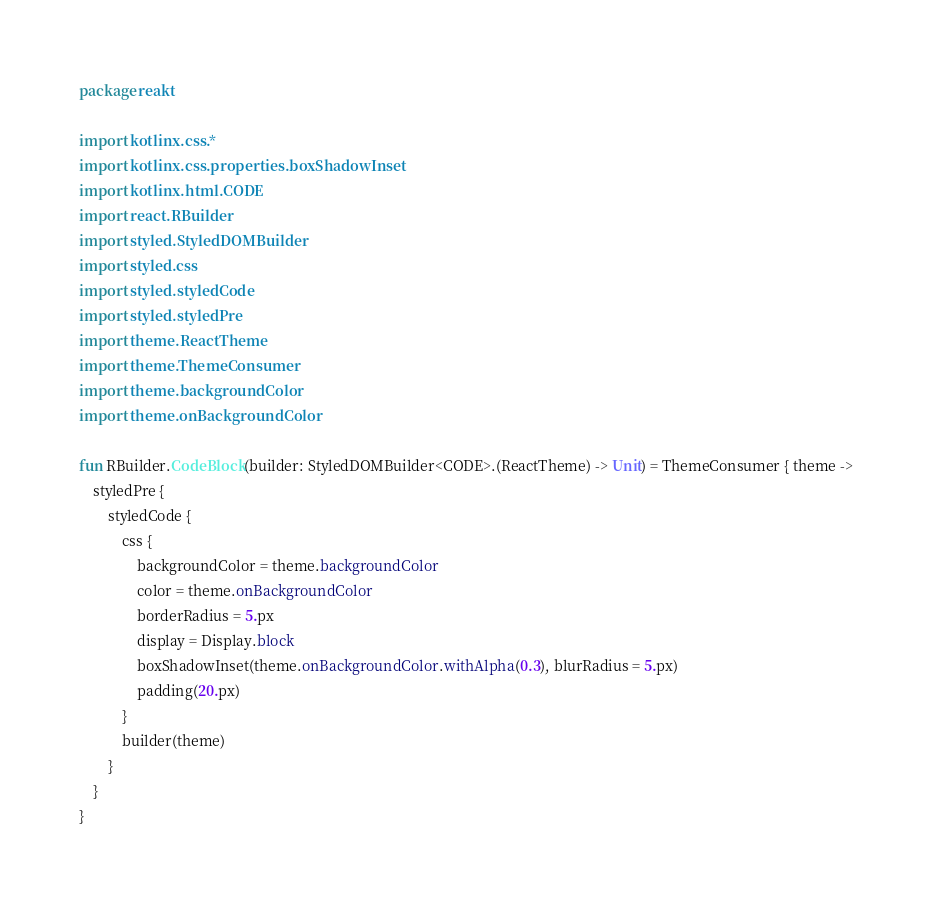Convert code to text. <code><loc_0><loc_0><loc_500><loc_500><_Kotlin_>package reakt

import kotlinx.css.*
import kotlinx.css.properties.boxShadowInset
import kotlinx.html.CODE
import react.RBuilder
import styled.StyledDOMBuilder
import styled.css
import styled.styledCode
import styled.styledPre
import theme.ReactTheme
import theme.ThemeConsumer
import theme.backgroundColor
import theme.onBackgroundColor

fun RBuilder.CodeBlock(builder: StyledDOMBuilder<CODE>.(ReactTheme) -> Unit) = ThemeConsumer { theme ->
    styledPre {
        styledCode {
            css {
                backgroundColor = theme.backgroundColor
                color = theme.onBackgroundColor
                borderRadius = 5.px
                display = Display.block
                boxShadowInset(theme.onBackgroundColor.withAlpha(0.3), blurRadius = 5.px)
                padding(20.px)
            }
            builder(theme)
        }
    }
}</code> 